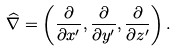Convert formula to latex. <formula><loc_0><loc_0><loc_500><loc_500>\widehat { \nabla } = \left ( \frac { \partial } { \partial x ^ { \prime } } , \frac { \partial } { \partial y ^ { \prime } } , \frac { \partial } { \partial z ^ { \prime } } \right ) .</formula> 